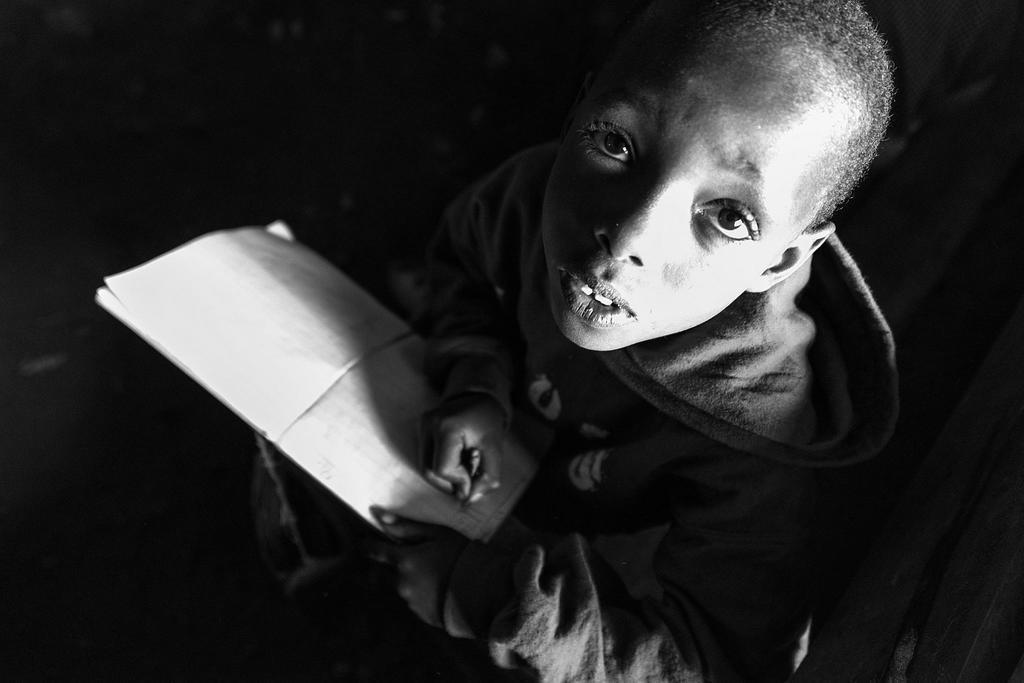Can you describe this image briefly? This is a black and white image. There is a boy holding a book and a pencil. 